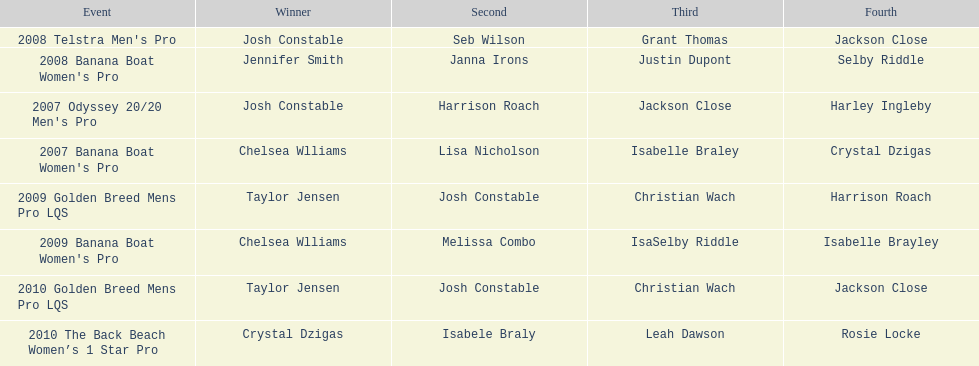Who completed the 2008 telstra men's pro following josh constable? Seb Wilson. I'm looking to parse the entire table for insights. Could you assist me with that? {'header': ['Event', 'Winner', 'Second', 'Third', 'Fourth'], 'rows': [["2008 Telstra Men's Pro", 'Josh Constable', 'Seb Wilson', 'Grant Thomas', 'Jackson Close'], ["2008 Banana Boat Women's Pro", 'Jennifer Smith', 'Janna Irons', 'Justin Dupont', 'Selby Riddle'], ["2007 Odyssey 20/20 Men's Pro", 'Josh Constable', 'Harrison Roach', 'Jackson Close', 'Harley Ingleby'], ["2007 Banana Boat Women's Pro", 'Chelsea Wlliams', 'Lisa Nicholson', 'Isabelle Braley', 'Crystal Dzigas'], ['2009 Golden Breed Mens Pro LQS', 'Taylor Jensen', 'Josh Constable', 'Christian Wach', 'Harrison Roach'], ["2009 Banana Boat Women's Pro", 'Chelsea Wlliams', 'Melissa Combo', 'IsaSelby Riddle', 'Isabelle Brayley'], ['2010 Golden Breed Mens Pro LQS', 'Taylor Jensen', 'Josh Constable', 'Christian Wach', 'Jackson Close'], ['2010 The Back Beach Women’s 1 Star Pro', 'Crystal Dzigas', 'Isabele Braly', 'Leah Dawson', 'Rosie Locke']]} 